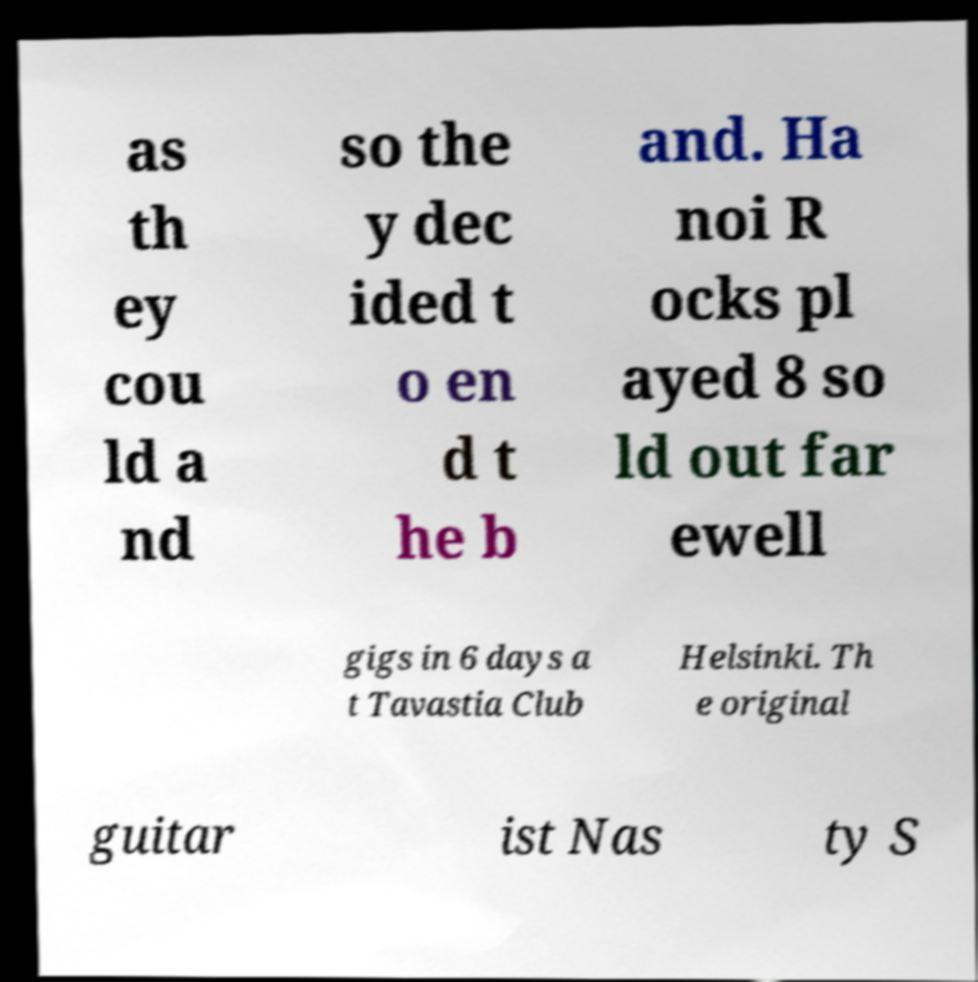Please read and relay the text visible in this image. What does it say? as th ey cou ld a nd so the y dec ided t o en d t he b and. Ha noi R ocks pl ayed 8 so ld out far ewell gigs in 6 days a t Tavastia Club Helsinki. Th e original guitar ist Nas ty S 